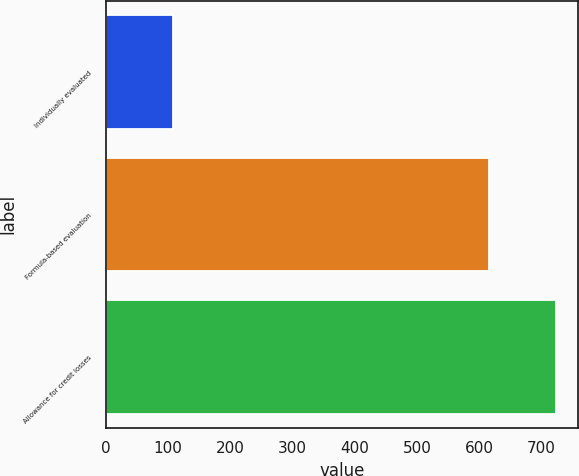Convert chart. <chart><loc_0><loc_0><loc_500><loc_500><bar_chart><fcel>Individually evaluated<fcel>Formula-based evaluation<fcel>Allowance for credit losses<nl><fcel>108<fcel>615<fcel>723<nl></chart> 